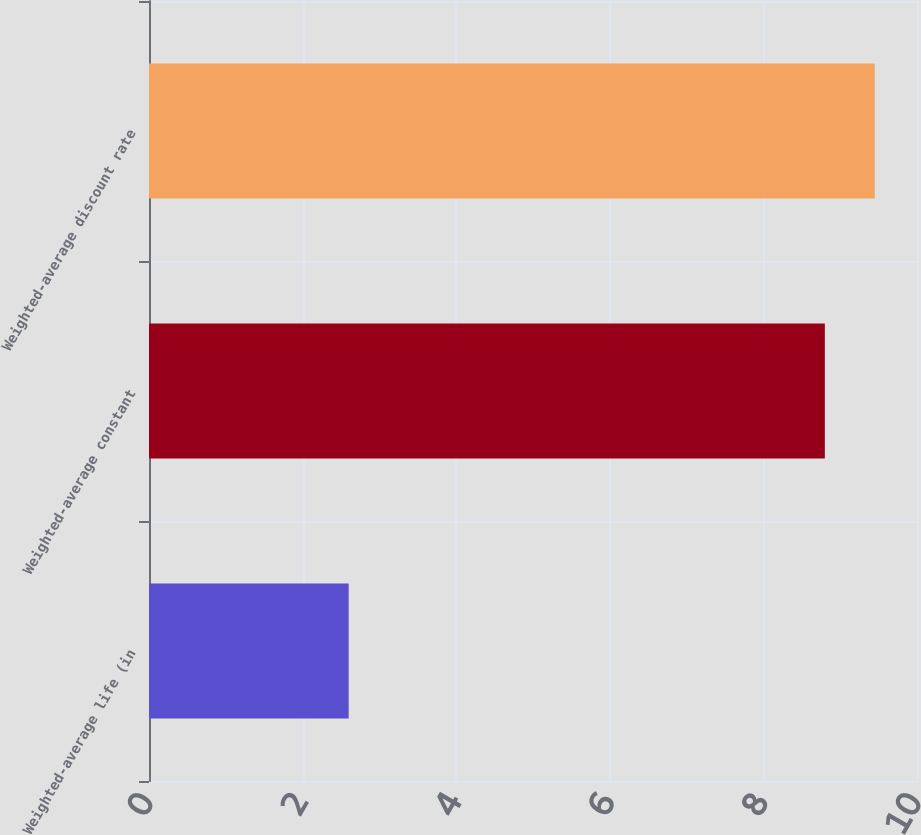<chart> <loc_0><loc_0><loc_500><loc_500><bar_chart><fcel>Weighted-average life (in<fcel>Weighted-average constant<fcel>Weighted-average discount rate<nl><fcel>2.6<fcel>8.8<fcel>9.45<nl></chart> 